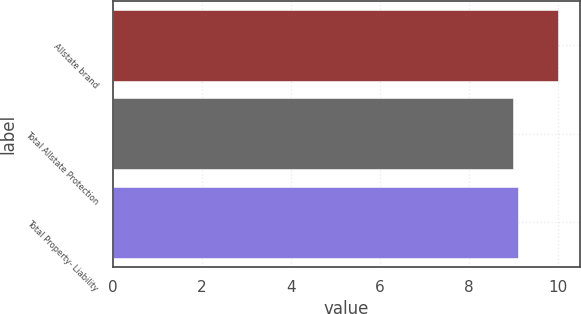<chart> <loc_0><loc_0><loc_500><loc_500><bar_chart><fcel>Allstate brand<fcel>Total Allstate Protection<fcel>Total Property- Liability<nl><fcel>10<fcel>9<fcel>9.1<nl></chart> 